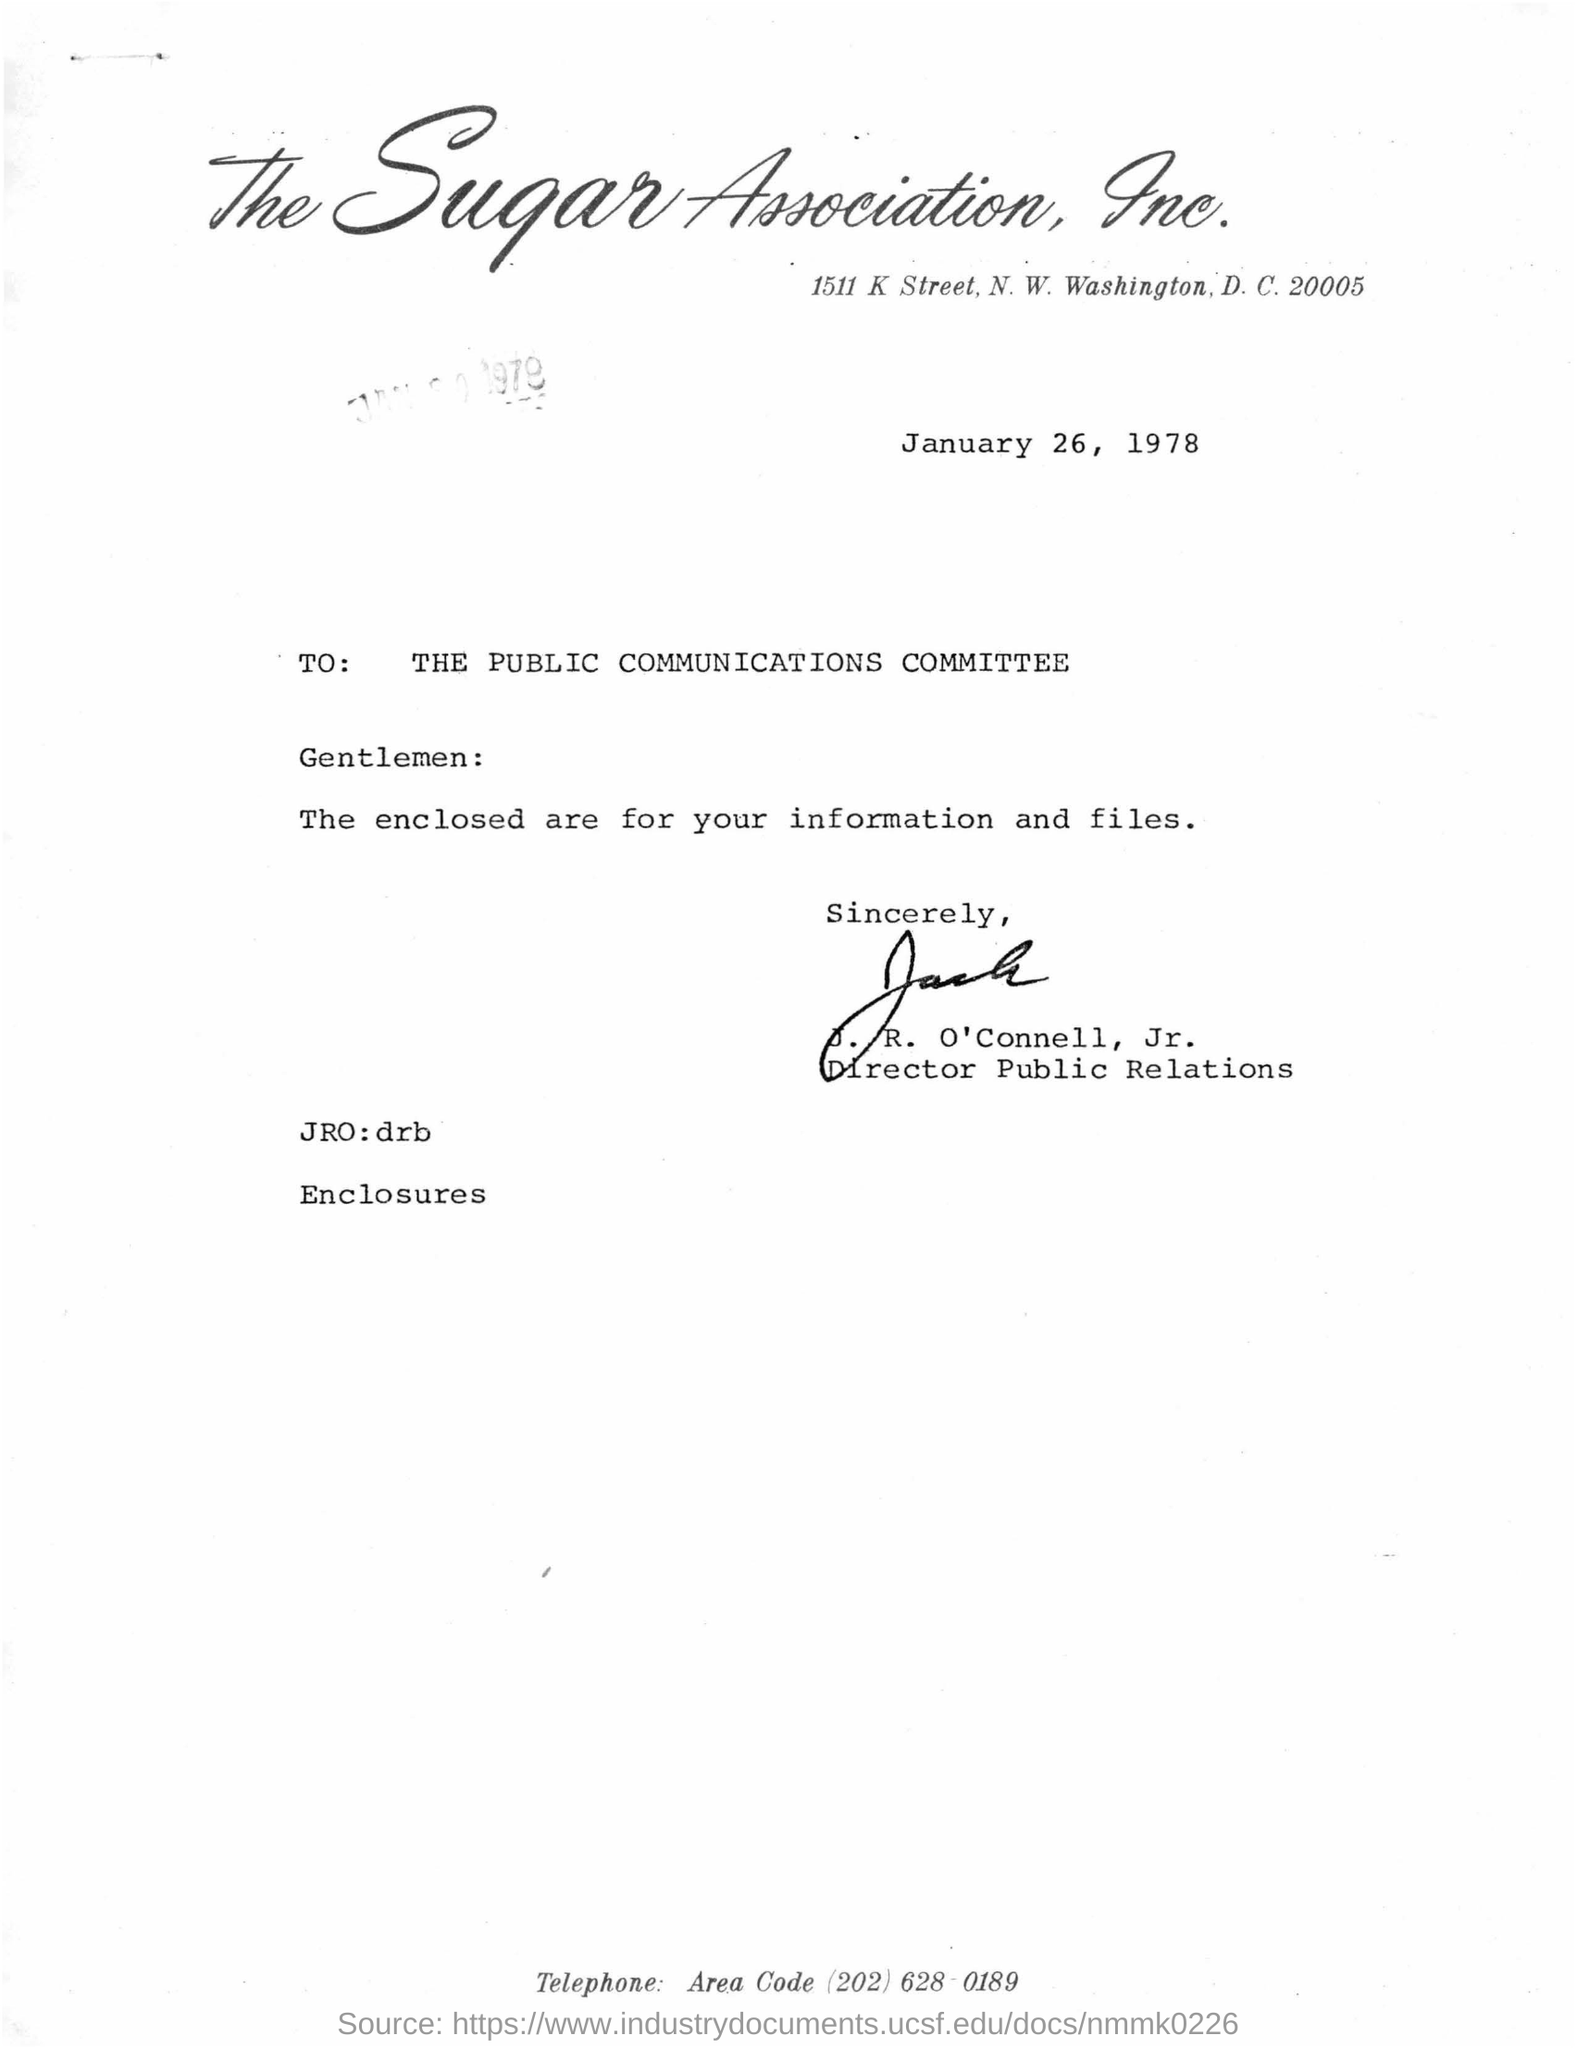Highlight a few significant elements in this photo. The date mentioned in the document is January 26, 1978. 